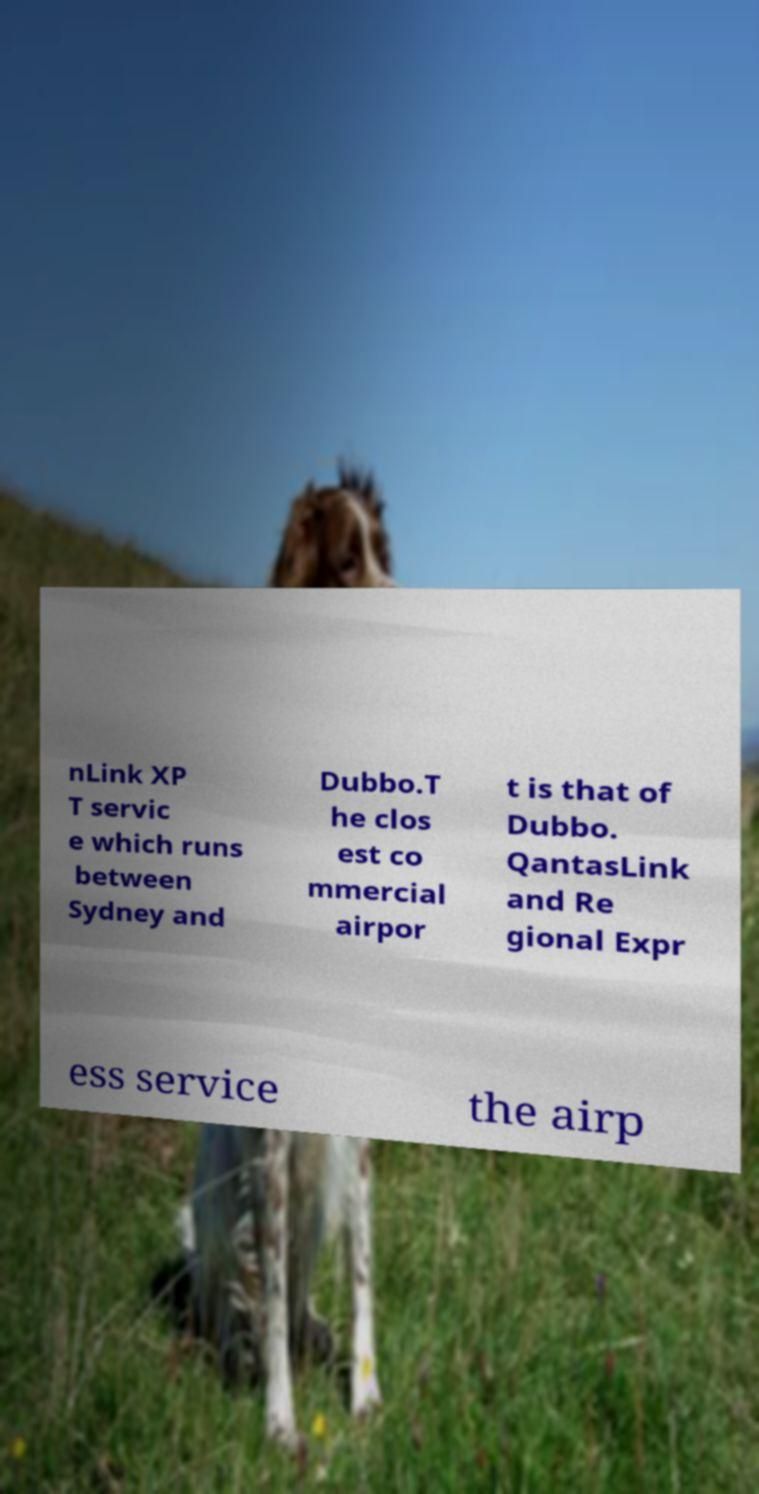Please read and relay the text visible in this image. What does it say? nLink XP T servic e which runs between Sydney and Dubbo.T he clos est co mmercial airpor t is that of Dubbo. QantasLink and Re gional Expr ess service the airp 